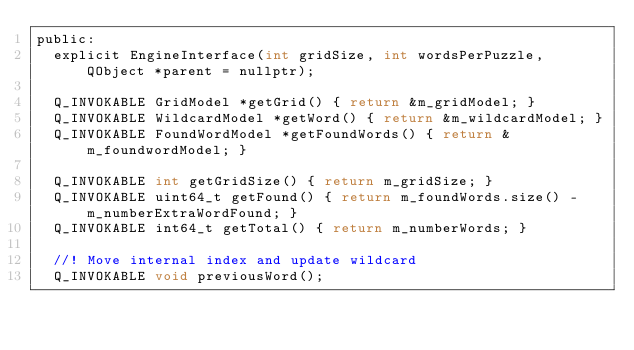<code> <loc_0><loc_0><loc_500><loc_500><_C_>public:
  explicit EngineInterface(int gridSize, int wordsPerPuzzle, QObject *parent = nullptr);

  Q_INVOKABLE GridModel *getGrid() { return &m_gridModel; }
  Q_INVOKABLE WildcardModel *getWord() { return &m_wildcardModel; }
  Q_INVOKABLE FoundWordModel *getFoundWords() { return &m_foundwordModel; }

  Q_INVOKABLE int getGridSize() { return m_gridSize; }
  Q_INVOKABLE uint64_t getFound() { return m_foundWords.size() - m_numberExtraWordFound; }
  Q_INVOKABLE int64_t getTotal() { return m_numberWords; }

  //! Move internal index and update wildcard
  Q_INVOKABLE void previousWord();</code> 